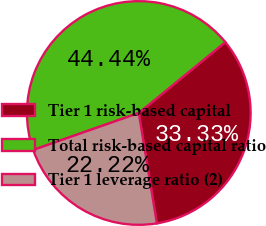Convert chart. <chart><loc_0><loc_0><loc_500><loc_500><pie_chart><fcel>Tier 1 risk-based capital<fcel>Total risk-based capital ratio<fcel>Tier 1 leverage ratio (2)<nl><fcel>33.33%<fcel>44.44%<fcel>22.22%<nl></chart> 